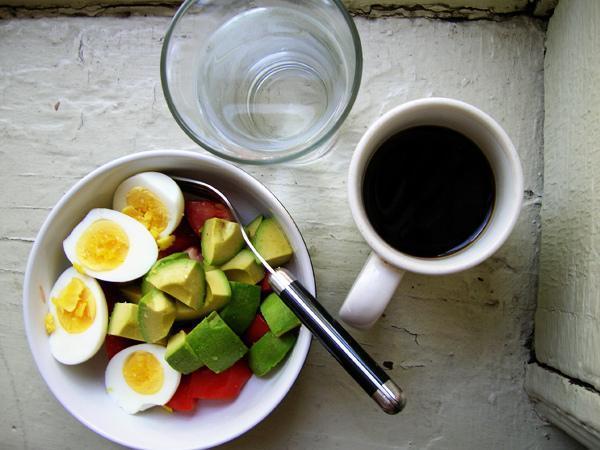How many egg slices are there?
Give a very brief answer. 4. How many people are probably going to eat this food?
Give a very brief answer. 1. How many bowls?
Give a very brief answer. 1. How many cups are visible?
Give a very brief answer. 2. 